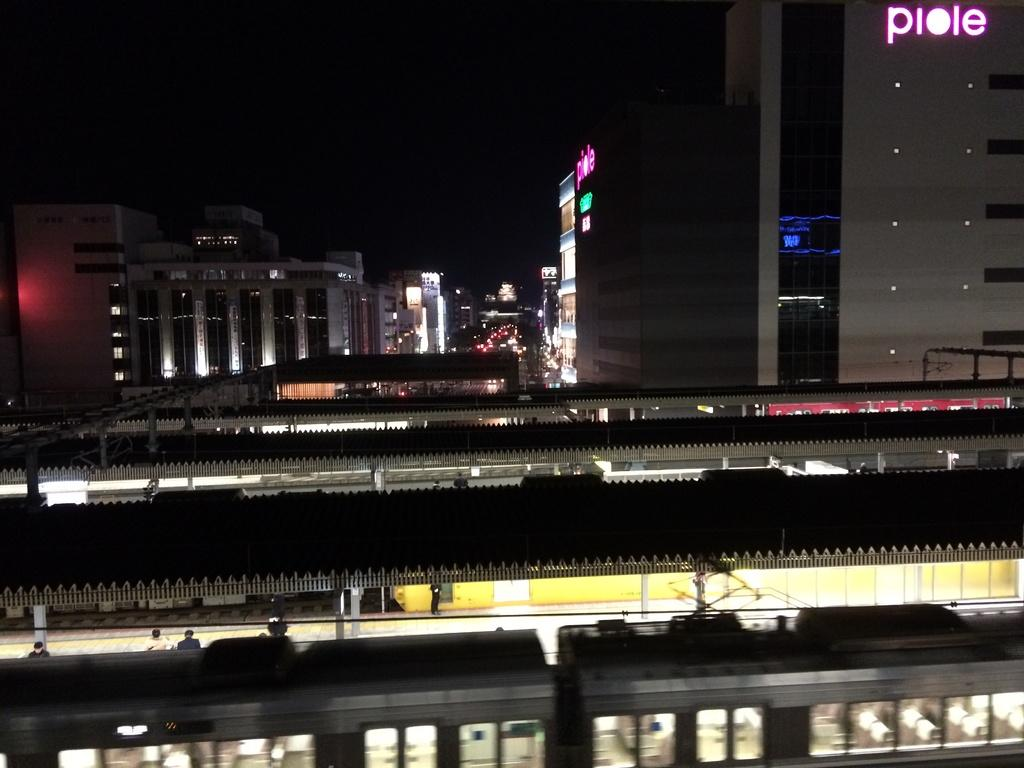Provide a one-sentence caption for the provided image. Behind a train in a large building with "piole" written on the side. 